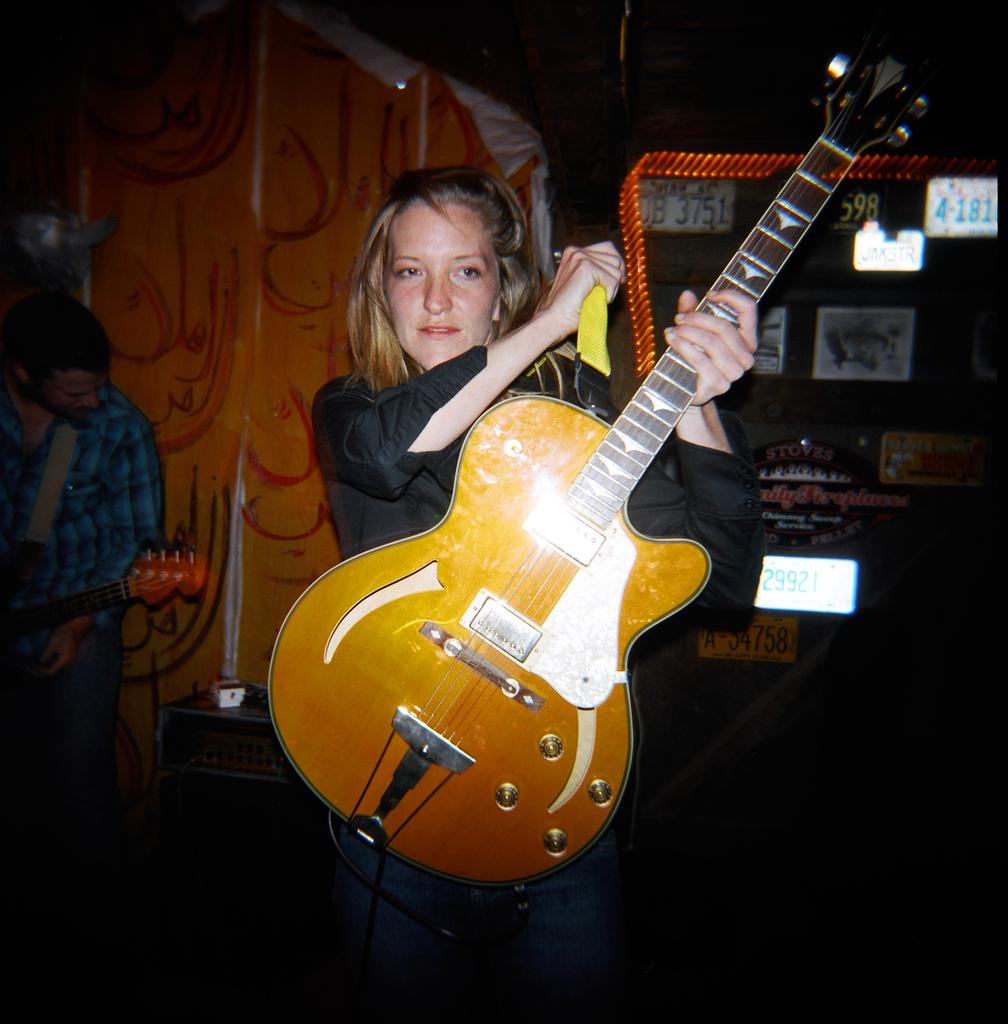What are the two people in the image holding? The two people in the image are holding guitars. Can you describe the background of the image? In the background, there are numbers on the wall. What caption is written on the tray in the image? There is no tray present in the image, so there is no caption to be read. 